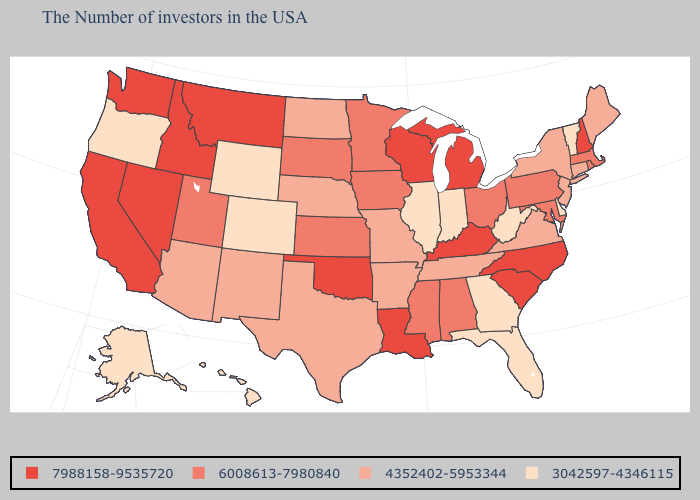Name the states that have a value in the range 7988158-9535720?
Write a very short answer. New Hampshire, North Carolina, South Carolina, Michigan, Kentucky, Wisconsin, Louisiana, Oklahoma, Montana, Idaho, Nevada, California, Washington. Name the states that have a value in the range 4352402-5953344?
Give a very brief answer. Maine, Connecticut, New York, New Jersey, Virginia, Tennessee, Missouri, Arkansas, Nebraska, Texas, North Dakota, New Mexico, Arizona. Which states have the lowest value in the West?
Answer briefly. Wyoming, Colorado, Oregon, Alaska, Hawaii. Name the states that have a value in the range 4352402-5953344?
Keep it brief. Maine, Connecticut, New York, New Jersey, Virginia, Tennessee, Missouri, Arkansas, Nebraska, Texas, North Dakota, New Mexico, Arizona. What is the value of Nevada?
Be succinct. 7988158-9535720. What is the value of New Jersey?
Quick response, please. 4352402-5953344. Does Michigan have the highest value in the MidWest?
Concise answer only. Yes. Among the states that border Illinois , which have the lowest value?
Quick response, please. Indiana. What is the lowest value in the MidWest?
Short answer required. 3042597-4346115. What is the value of Illinois?
Keep it brief. 3042597-4346115. Name the states that have a value in the range 6008613-7980840?
Concise answer only. Massachusetts, Rhode Island, Maryland, Pennsylvania, Ohio, Alabama, Mississippi, Minnesota, Iowa, Kansas, South Dakota, Utah. Which states have the lowest value in the Northeast?
Keep it brief. Vermont. What is the highest value in states that border Minnesota?
Quick response, please. 7988158-9535720. What is the value of Michigan?
Quick response, please. 7988158-9535720. Which states hav the highest value in the MidWest?
Quick response, please. Michigan, Wisconsin. 